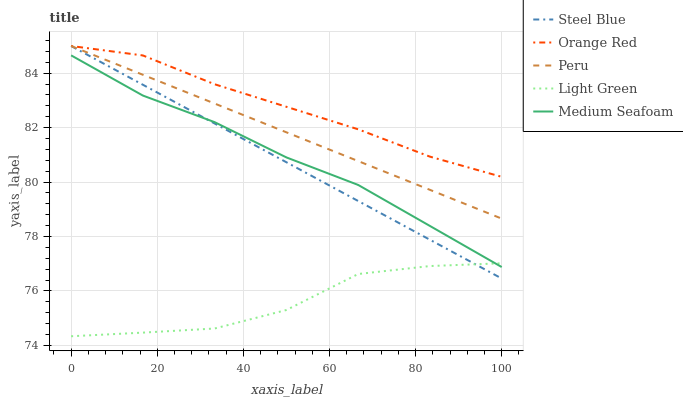Does Light Green have the minimum area under the curve?
Answer yes or no. Yes. Does Orange Red have the maximum area under the curve?
Answer yes or no. Yes. Does Steel Blue have the minimum area under the curve?
Answer yes or no. No. Does Steel Blue have the maximum area under the curve?
Answer yes or no. No. Is Peru the smoothest?
Answer yes or no. Yes. Is Light Green the roughest?
Answer yes or no. Yes. Is Steel Blue the smoothest?
Answer yes or no. No. Is Steel Blue the roughest?
Answer yes or no. No. Does Light Green have the lowest value?
Answer yes or no. Yes. Does Steel Blue have the lowest value?
Answer yes or no. No. Does Orange Red have the highest value?
Answer yes or no. Yes. Does Light Green have the highest value?
Answer yes or no. No. Is Medium Seafoam less than Orange Red?
Answer yes or no. Yes. Is Orange Red greater than Medium Seafoam?
Answer yes or no. Yes. Does Orange Red intersect Peru?
Answer yes or no. Yes. Is Orange Red less than Peru?
Answer yes or no. No. Is Orange Red greater than Peru?
Answer yes or no. No. Does Medium Seafoam intersect Orange Red?
Answer yes or no. No. 